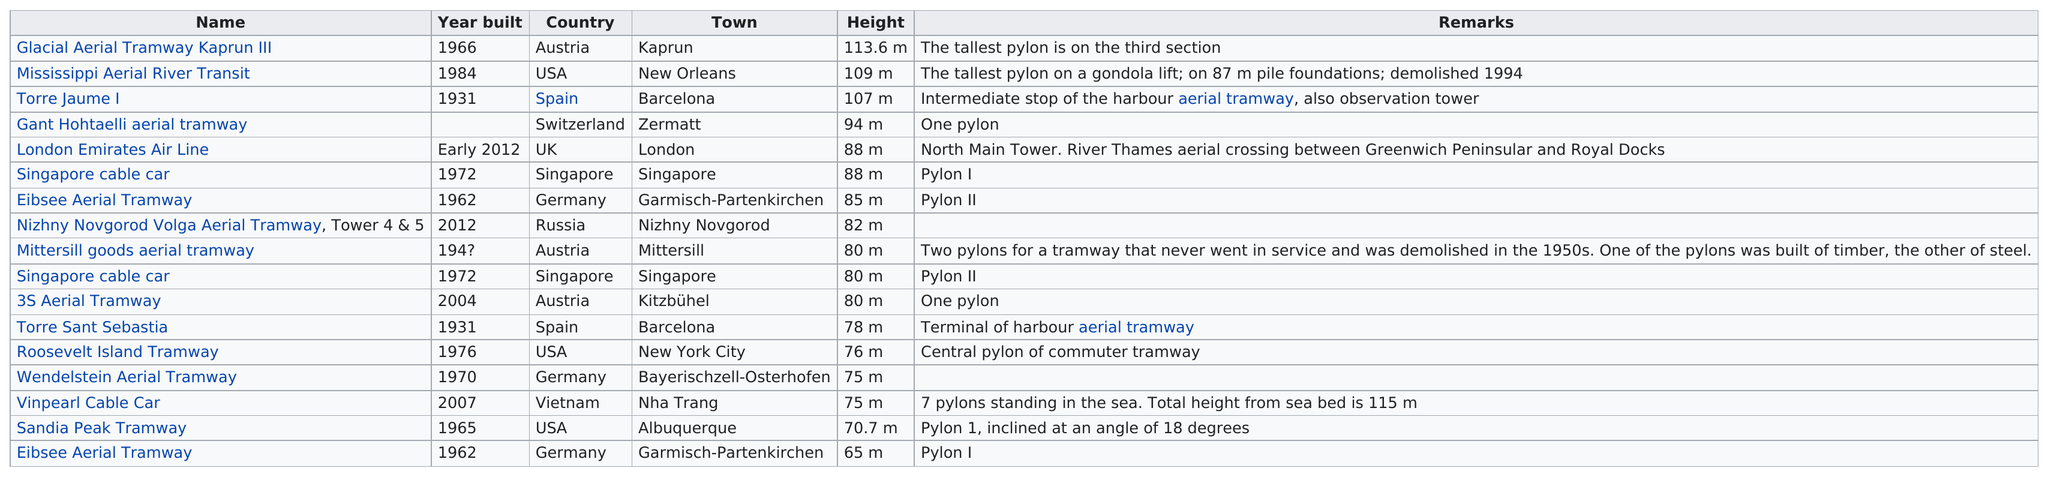Specify some key components in this picture. The tallest pylon is 113.6 meters high. In the year 1970, the last pylon was constructed in Germany. The Mittersill goods aerial tramway has the most comments and remarks about it. The Eibsee Aerial Tramway features the pylon with the least height among all listed. The total number of pylons listed is 17. 